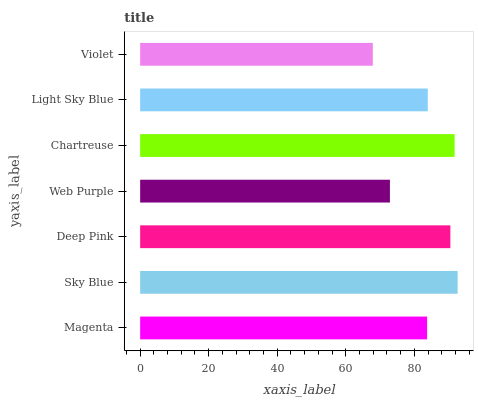Is Violet the minimum?
Answer yes or no. Yes. Is Sky Blue the maximum?
Answer yes or no. Yes. Is Deep Pink the minimum?
Answer yes or no. No. Is Deep Pink the maximum?
Answer yes or no. No. Is Sky Blue greater than Deep Pink?
Answer yes or no. Yes. Is Deep Pink less than Sky Blue?
Answer yes or no. Yes. Is Deep Pink greater than Sky Blue?
Answer yes or no. No. Is Sky Blue less than Deep Pink?
Answer yes or no. No. Is Light Sky Blue the high median?
Answer yes or no. Yes. Is Light Sky Blue the low median?
Answer yes or no. Yes. Is Violet the high median?
Answer yes or no. No. Is Web Purple the low median?
Answer yes or no. No. 